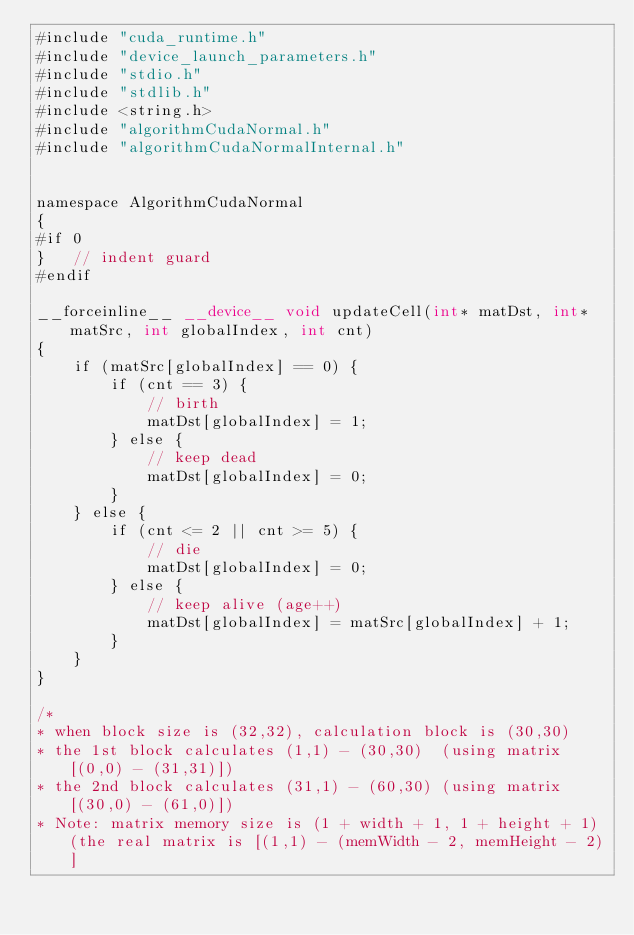<code> <loc_0><loc_0><loc_500><loc_500><_Cuda_>#include "cuda_runtime.h"
#include "device_launch_parameters.h"
#include "stdio.h"
#include "stdlib.h"
#include <string.h>
#include "algorithmCudaNormal.h"
#include "algorithmCudaNormalInternal.h"


namespace AlgorithmCudaNormal
{
#if 0
}	// indent guard
#endif

__forceinline__ __device__ void updateCell(int* matDst, int* matSrc, int globalIndex, int cnt)
{
	if (matSrc[globalIndex] == 0) {
		if (cnt == 3) {
			// birth
			matDst[globalIndex] = 1;
		} else {
			// keep dead
			matDst[globalIndex] = 0;
		}
	} else {
		if (cnt <= 2 || cnt >= 5) {
			// die
			matDst[globalIndex] = 0;
		} else {
			// keep alive (age++)
			matDst[globalIndex] = matSrc[globalIndex] + 1;
		}
	}
}

/*
* when block size is (32,32), calculation block is (30,30)
* the 1st block calculates (1,1) - (30,30)  (using matrix[(0,0) - (31,31)])
* the 2nd block calculates (31,1) - (60,30) (using matrix[(30,0) - (61,0)])
* Note: matrix memory size is (1 + width + 1, 1 + height + 1) (the real matrix is [(1,1) - (memWidth - 2, memHeight - 2)]</code> 